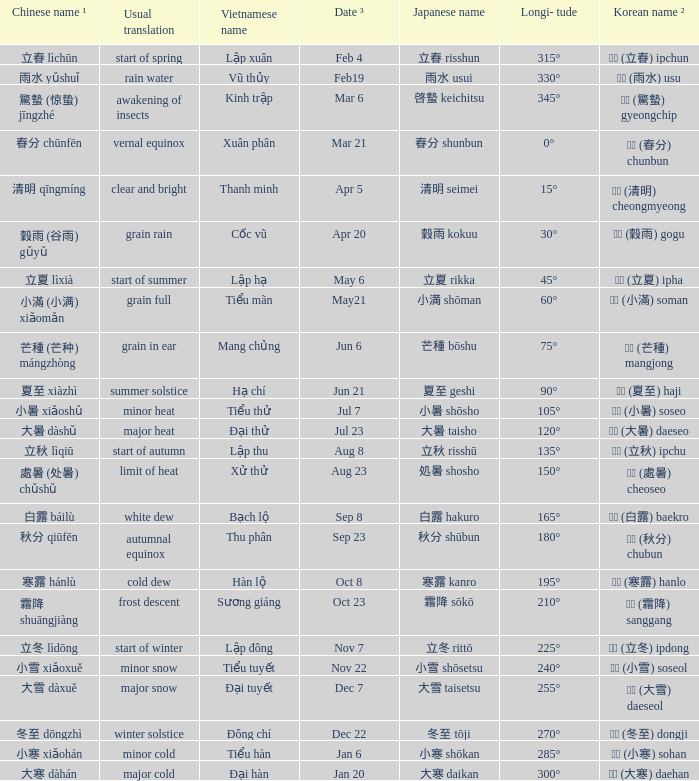WHich Usual translation is on sep 23? Autumnal equinox. 